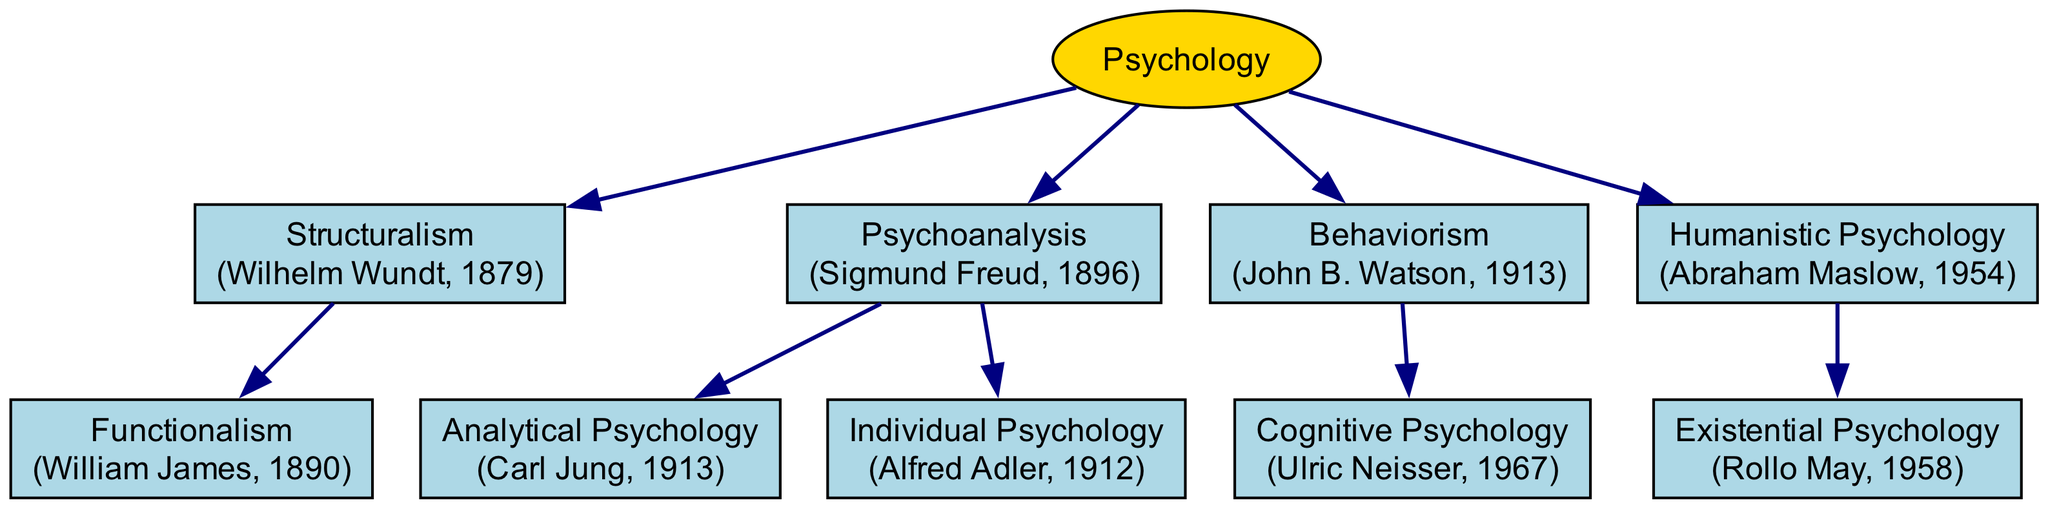What is the year of the founding of Structuralism? The diagram shows that Structuralism was founded by Wilhelm Wundt in 1879.
Answer: 1879 Who founded Psychoanalysis? According to the diagram, Psychoanalysis was founded by Sigmund Freud.
Answer: Sigmund Freud How many offspring does Behaviorism have? The diagram indicates that Behaviorism has one offspring, which is Cognitive Psychology.
Answer: 1 What is the root of the family tree? The diagram clearly states that the root of the family tree is Psychology.
Answer: Psychology Which school of thought emerged from Functionalism? Analyzing the diagram, it shows there are no direct offspring from Functionalism; thus, it has no descendants.
Answer: None Name one founder of the offspring of Psychoanalysis. On the diagram, the offspring of Psychoanalysis include both Carl Jung and Alfred Adler.
Answer: Carl Jung or Alfred Adler What is the relationship between Humanistic Psychology and Existential Psychology? The diagram illustrates that Existential Psychology is an offspring of Humanistic Psychology, indicating a direct descent.
Answer: Offspring Which psychological theory was established in 1954? Referring to the diagram, Humanistic Psychology was founded in 1954.
Answer: Humanistic Psychology How many branches are depicted in the family tree? Counting the branches in the diagram, there are four main branches emerging from the root Psychology.
Answer: 4 